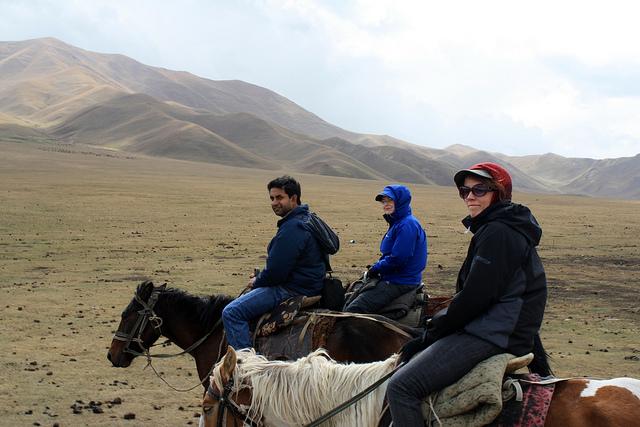What is the sex of the person with nothing covering the head?
Concise answer only. Male. What are the people riding?
Quick response, please. Horses. Are they riding in the jungle?
Short answer required. No. How many people are wearing sunglasses?
Keep it brief. 1. How many people are there?
Quick response, please. 3. 